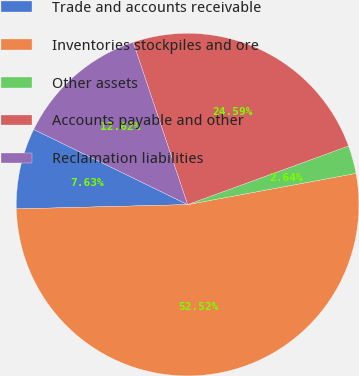Convert chart to OTSL. <chart><loc_0><loc_0><loc_500><loc_500><pie_chart><fcel>Trade and accounts receivable<fcel>Inventories stockpiles and ore<fcel>Other assets<fcel>Accounts payable and other<fcel>Reclamation liabilities<nl><fcel>7.63%<fcel>52.52%<fcel>2.64%<fcel>24.59%<fcel>12.62%<nl></chart> 